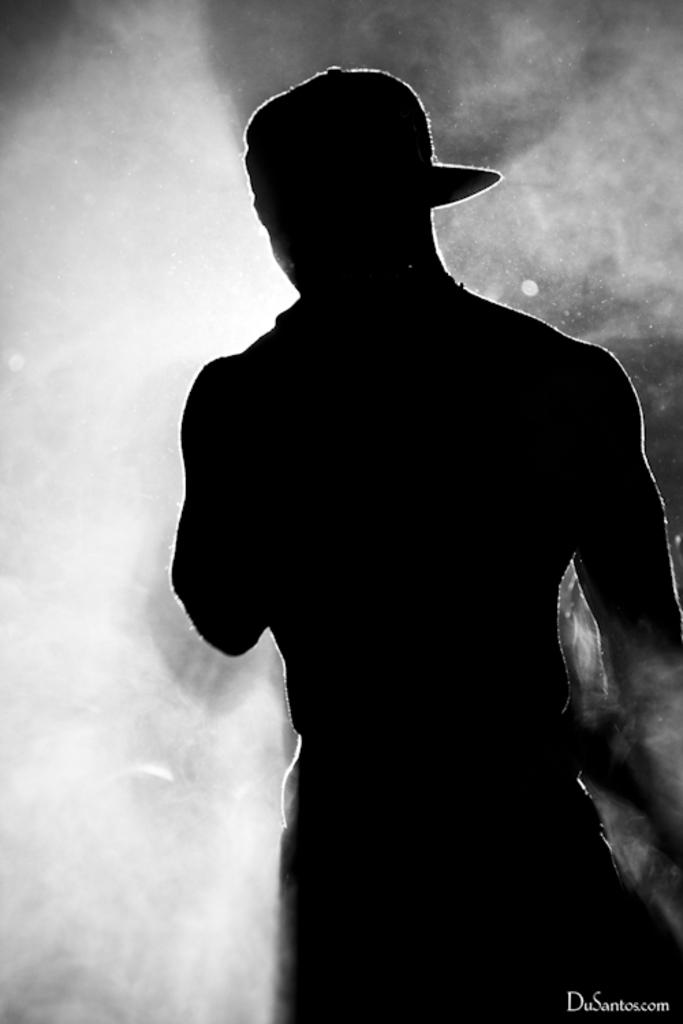What is the color scheme of the image? The image is black and white. Can you describe the main subject in the image? There is a man standing in the image. Reasoning: Let's think step by identifying the main subject and the color scheme of the image. We start by mentioning the color scheme, which is black and white. Then, we identify the main subject, which is a man standing in the image. We avoid asking questions that cannot be answered definitively based on the provided facts. Absurd Question/Answer: How many books can be seen on the sea in the image? There are no books or sea present in the image; it features a man standing in a black and white setting. Can you tell me how many crackers are on the man's head in the image? There are no crackers present in the image; it features a man standing in a black and white setting. 